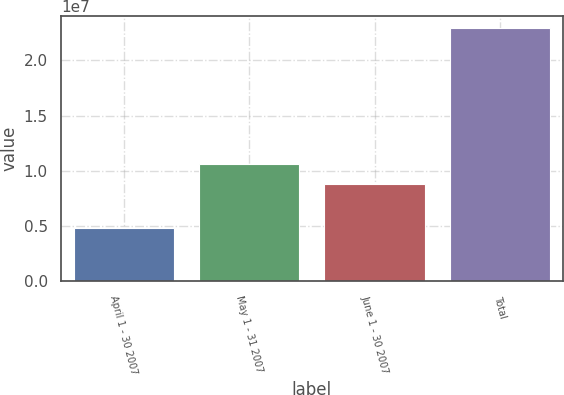Convert chart to OTSL. <chart><loc_0><loc_0><loc_500><loc_500><bar_chart><fcel>April 1 - 30 2007<fcel>May 1 - 31 2007<fcel>June 1 - 30 2007<fcel>Total<nl><fcel>4.78852e+06<fcel>1.06641e+07<fcel>8.85181e+06<fcel>2.29114e+07<nl></chart> 